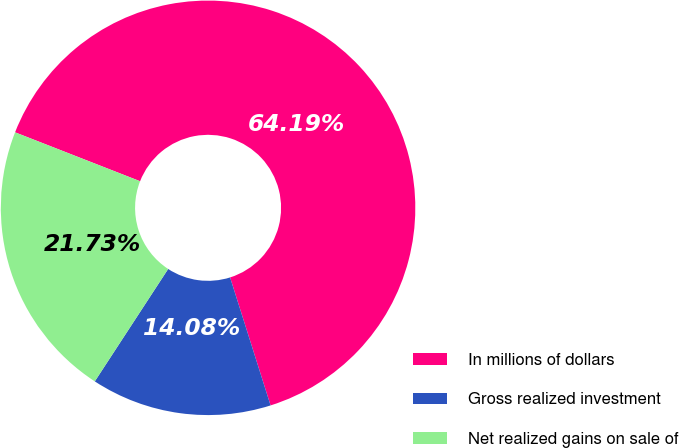<chart> <loc_0><loc_0><loc_500><loc_500><pie_chart><fcel>In millions of dollars<fcel>Gross realized investment<fcel>Net realized gains on sale of<nl><fcel>64.19%<fcel>14.08%<fcel>21.73%<nl></chart> 